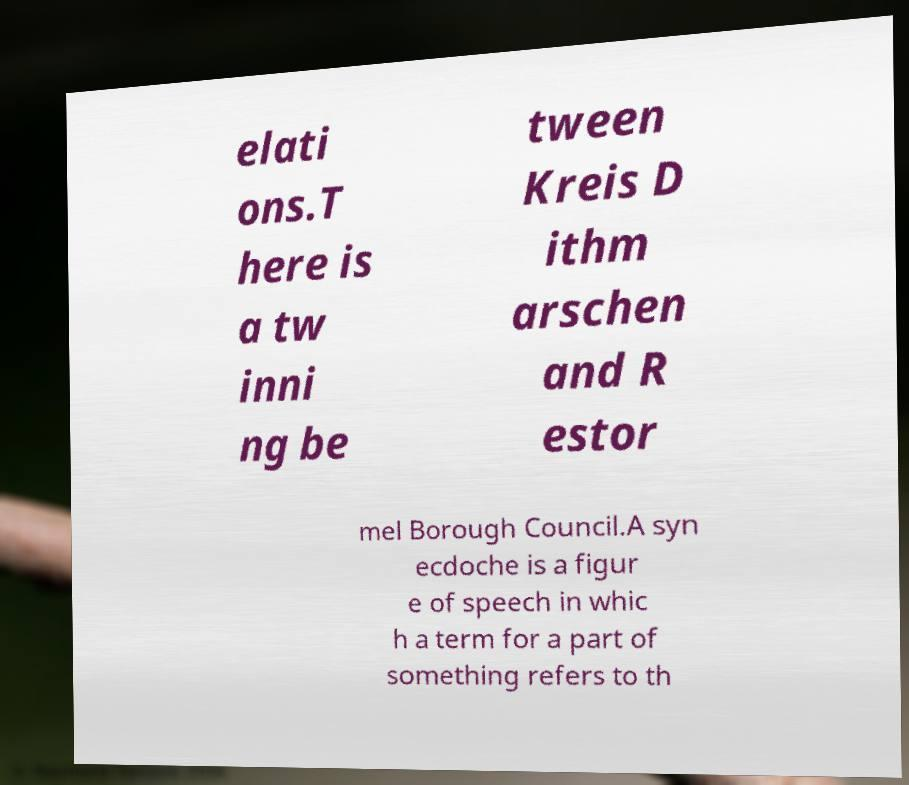There's text embedded in this image that I need extracted. Can you transcribe it verbatim? elati ons.T here is a tw inni ng be tween Kreis D ithm arschen and R estor mel Borough Council.A syn ecdoche is a figur e of speech in whic h a term for a part of something refers to th 